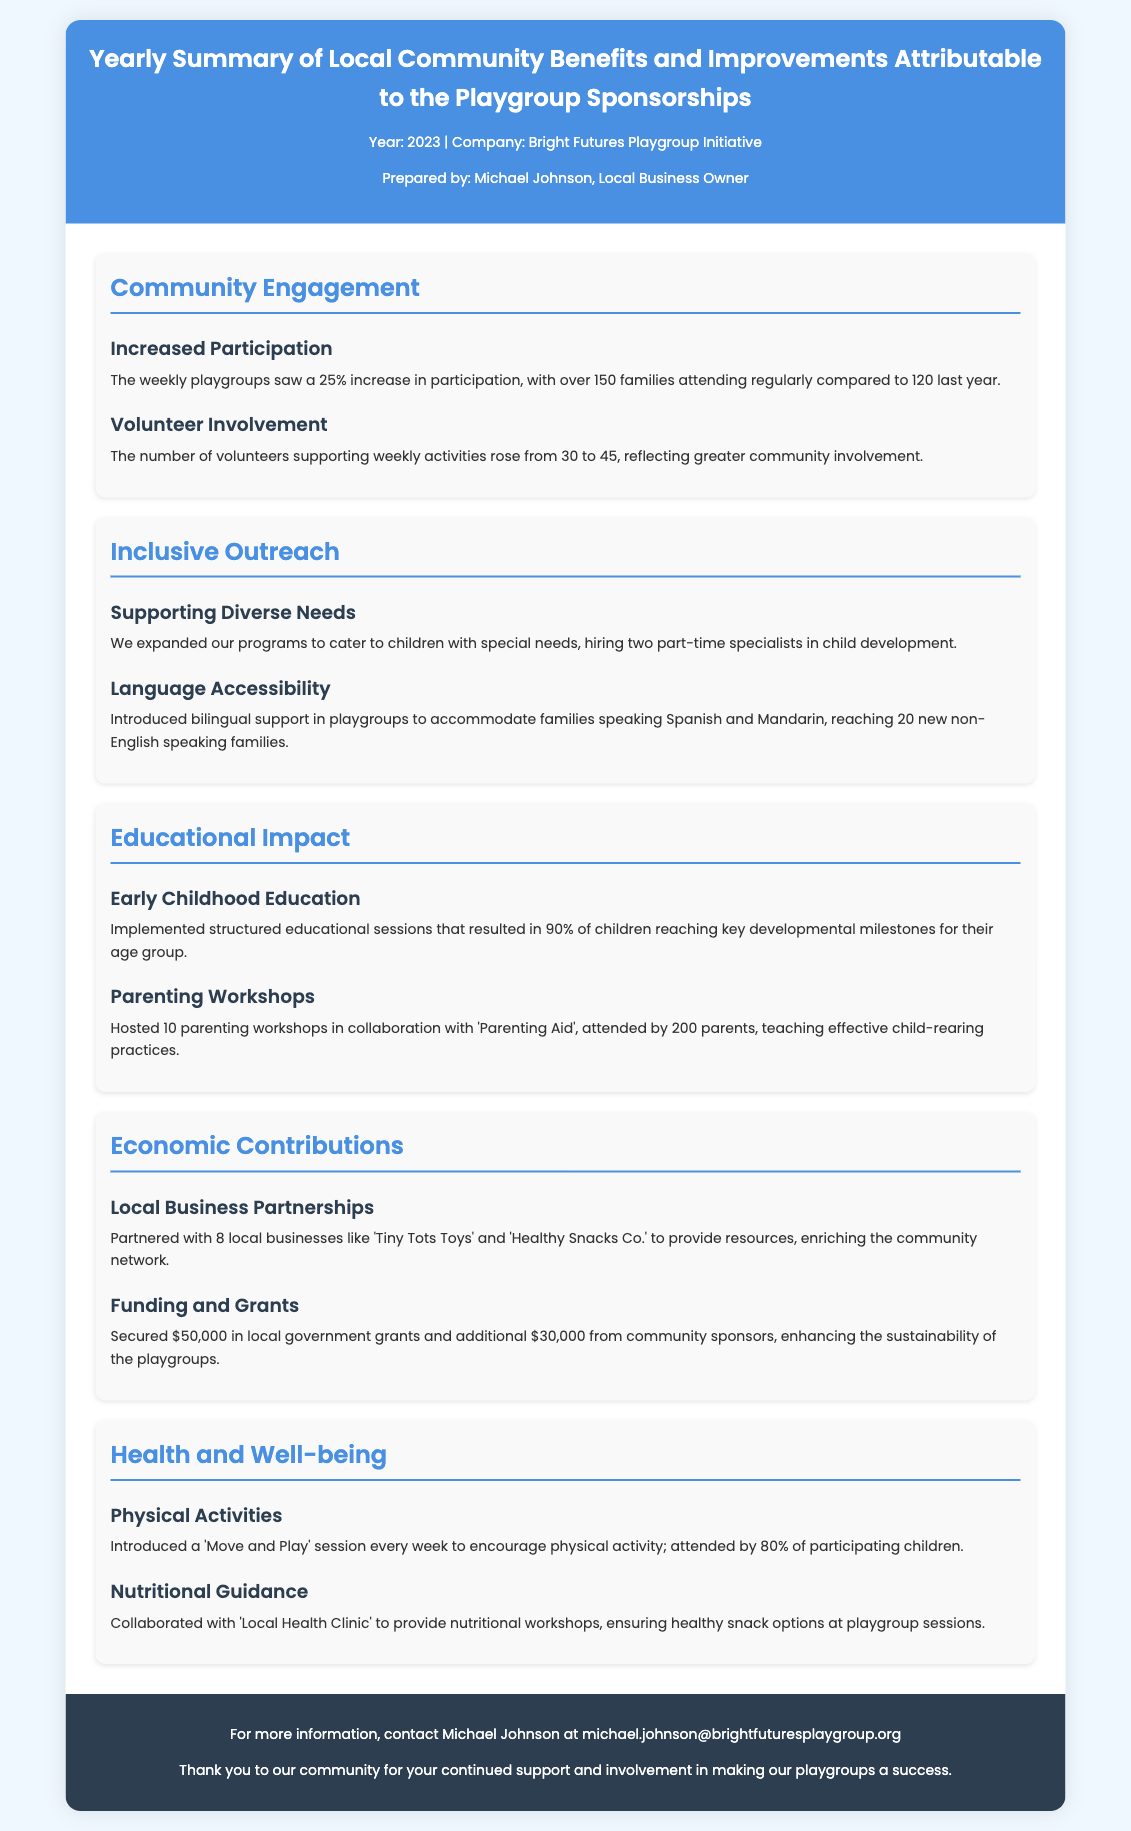What was the increase in participation at the playgroups? The document states that there was a 25% increase in participation, with over 150 families attending regularly compared to 120 last year.
Answer: 25% How many volunteers supported weekly activities this year? The report indicates that the number of volunteers rose from 30 to 45.
Answer: 45 What languages were supported for accessibility in the playgroups? The document mentions that bilingual support was introduced for families speaking Spanish and Mandarin.
Answer: Spanish and Mandarin How many parenting workshops were hosted, and how many parents attended? The report specifies that 10 parenting workshops were hosted, attended by 200 parents.
Answer: 10 workshops, 200 parents What was the total amount secured from local government grants? According to the document, $50,000 was secured in local government grants.
Answer: $50,000 Which local businesses partnered with the playgroup initiative? The document lists partnerships with 8 local businesses, including 'Tiny Tots Toys' and 'Healthy Snacks Co.'
Answer: 8 local businesses What percentage of children attended the 'Move and Play' session? The document states that 80% of participating children attended the 'Move and Play' session.
Answer: 80% What organization did the playgroup collaborate with for nutritional workshops? The report mentions collaboration with the 'Local Health Clinic' for providing nutritional workshops.
Answer: Local Health Clinic 